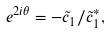Convert formula to latex. <formula><loc_0><loc_0><loc_500><loc_500>e ^ { 2 i \theta } = - \tilde { c } _ { 1 } / \tilde { c } _ { 1 } ^ { * } ,</formula> 